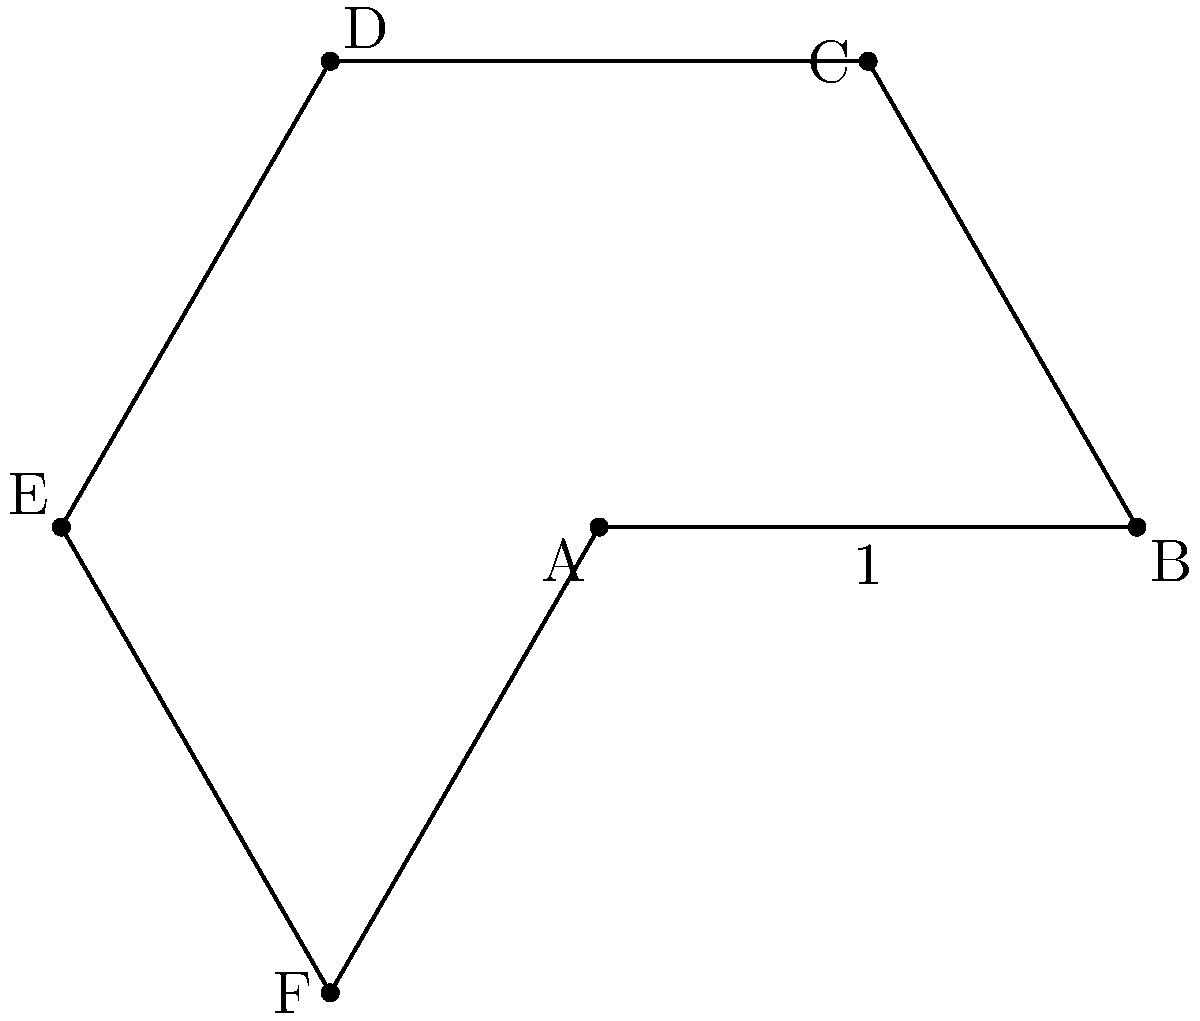Imagine you're designing a stage for Shakira's next concert, and you want to use a hexagonal platform. If one side of the hexagonal stage measures 1 meter, what would be the total area of the stage in square meters? (Round your answer to two decimal places) Let's break this down step-by-step:

1) The formula for the area of a regular hexagon is:

   $$A = \frac{3\sqrt{3}}{2}s^2$$

   where $s$ is the length of one side.

2) We're given that $s = 1$ meter.

3) Let's substitute this into our formula:

   $$A = \frac{3\sqrt{3}}{2}(1)^2$$

4) Simplify:
   $$A = \frac{3\sqrt{3}}{2}$$

5) Now, let's calculate this:
   
   $\sqrt{3} \approx 1.7321$
   
   $3 * 1.7321 \approx 5.1962$
   
   $5.1962 / 2 \approx 2.5981$

6) Rounding to two decimal places:

   $A \approx 2.60$ square meters

So, Shakira's hexagonal stage would have an area of approximately 2.60 square meters.
Answer: 2.60 square meters 